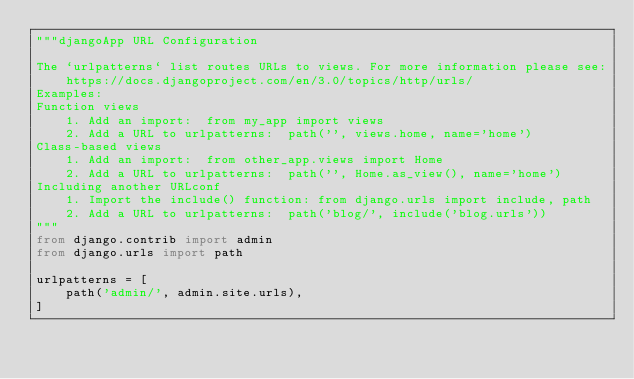<code> <loc_0><loc_0><loc_500><loc_500><_Python_>"""djangoApp URL Configuration

The `urlpatterns` list routes URLs to views. For more information please see:
    https://docs.djangoproject.com/en/3.0/topics/http/urls/
Examples:
Function views
    1. Add an import:  from my_app import views
    2. Add a URL to urlpatterns:  path('', views.home, name='home')
Class-based views
    1. Add an import:  from other_app.views import Home
    2. Add a URL to urlpatterns:  path('', Home.as_view(), name='home')
Including another URLconf
    1. Import the include() function: from django.urls import include, path
    2. Add a URL to urlpatterns:  path('blog/', include('blog.urls'))
"""
from django.contrib import admin
from django.urls import path

urlpatterns = [
    path('admin/', admin.site.urls),
]
</code> 